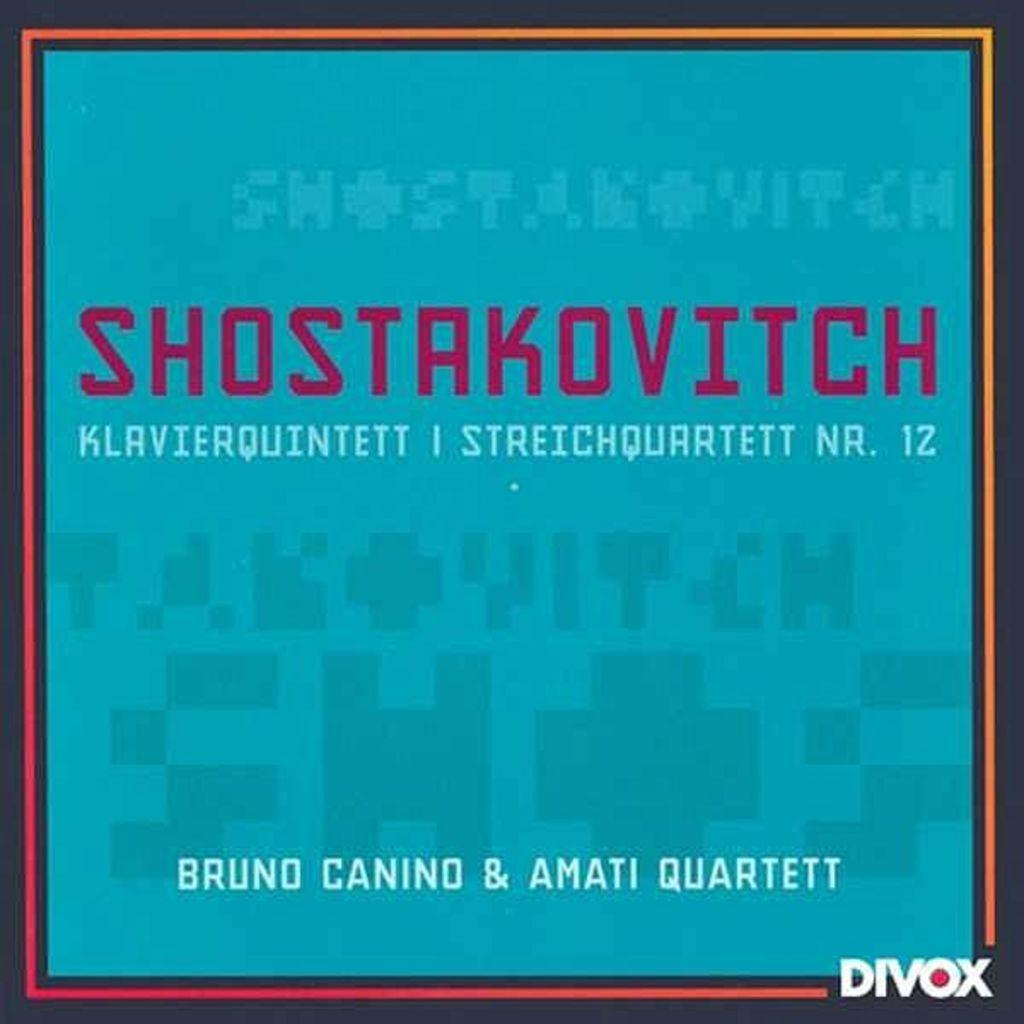What is present in the image that contains information or a message? There is a poster in the image that contains information or a message. Can you describe the text on the poster? The poster has text on it, but the specific content of the text is not mentioned in the provided facts. What type of curtain is hanging in front of the poster in the image? There is no curtain present in the image; only the poster is mentioned. How does the butter contribute to the message on the poster in the image? There is no butter present in the image, so it cannot contribute to the message on the poster. 